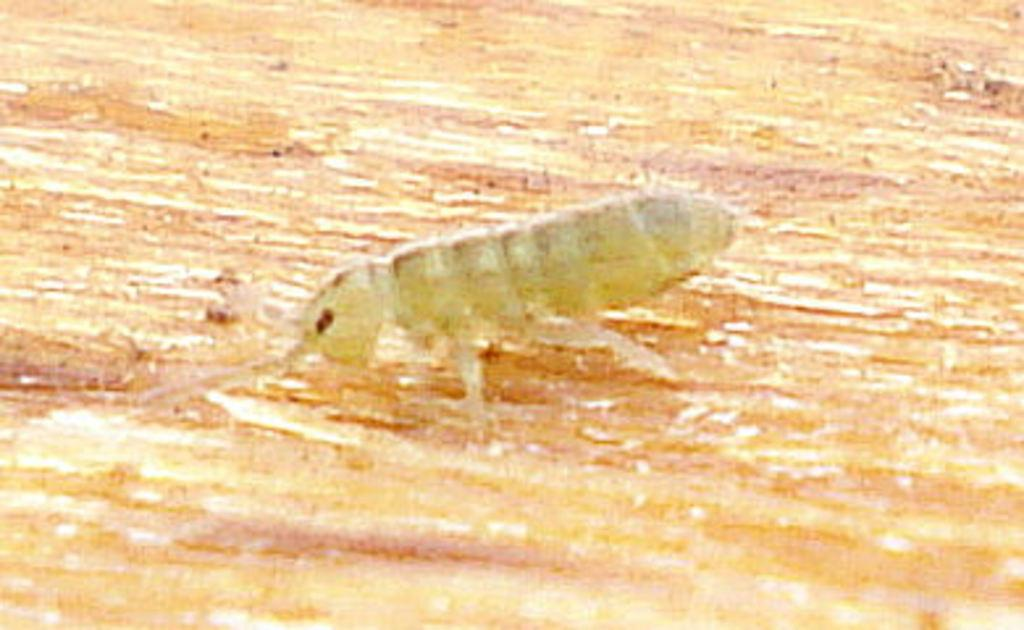What type of creature is present in the image? There is an insect in the image. Where is the insect located in the image? The insect is on a surface. What type of trick does the insect perform in the image? There is no trick being performed by the insect in the image; it is simply present on a surface. 